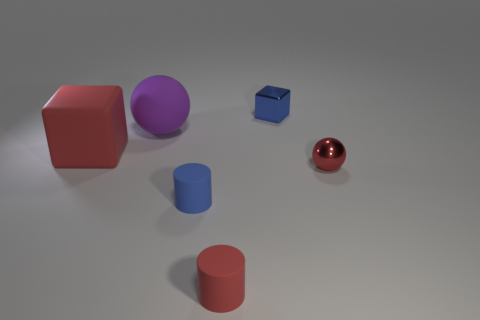There is a small ball that is the same color as the large block; what material is it?
Keep it short and to the point. Metal. The red thing on the right side of the red matte object on the right side of the cube to the left of the big purple rubber ball is what shape?
Offer a terse response. Sphere. There is a blue thing to the right of the small blue object that is on the left side of the red cylinder; what is it made of?
Provide a short and direct response. Metal. Is there a gray rubber object that has the same size as the red metallic thing?
Provide a succinct answer. No. What number of things are red matte things that are to the right of the large purple sphere or small objects that are on the left side of the blue metallic thing?
Make the answer very short. 2. Do the shiny thing right of the small blue cube and the red rubber thing in front of the large matte block have the same size?
Keep it short and to the point. Yes. There is a tiny blue metal thing that is behind the red metal object; is there a tiny red matte thing behind it?
Keep it short and to the point. No. There is a tiny blue rubber thing; how many blue metal cubes are on the left side of it?
Make the answer very short. 0. What number of other things are there of the same color as the tiny shiny block?
Your response must be concise. 1. Is the number of small blue objects in front of the red block less than the number of blue shiny cubes to the right of the red metal sphere?
Your response must be concise. No. 